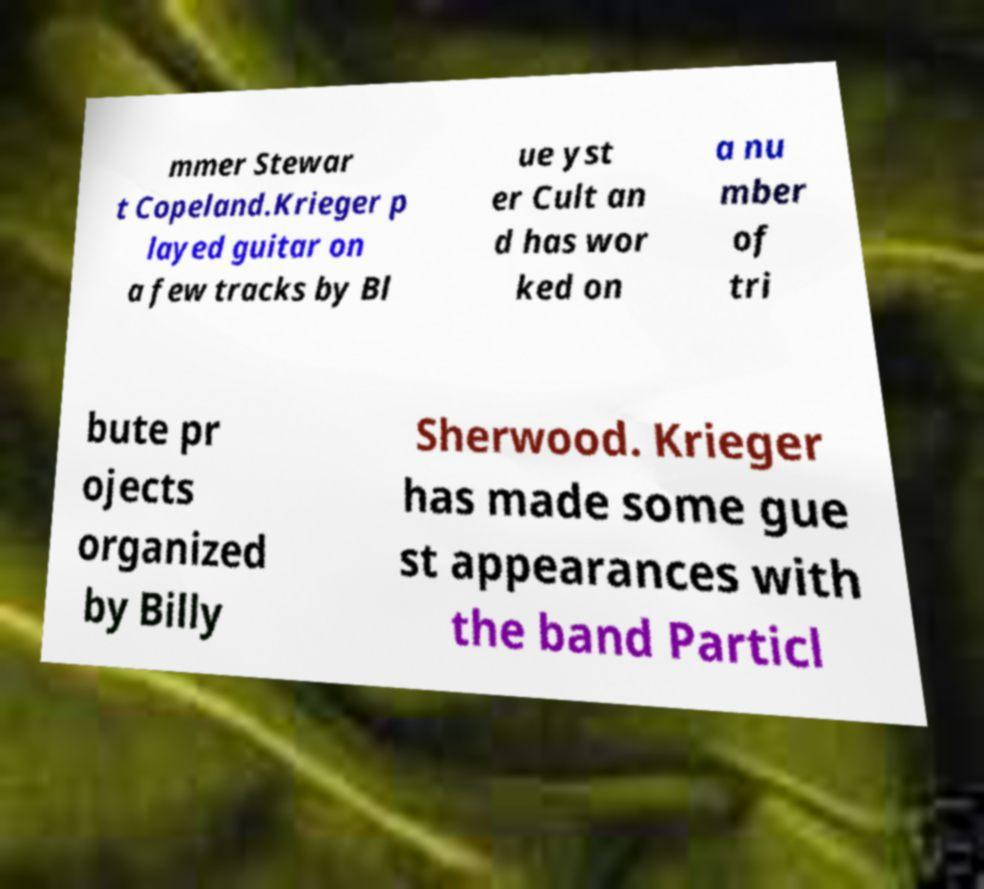What messages or text are displayed in this image? I need them in a readable, typed format. mmer Stewar t Copeland.Krieger p layed guitar on a few tracks by Bl ue yst er Cult an d has wor ked on a nu mber of tri bute pr ojects organized by Billy Sherwood. Krieger has made some gue st appearances with the band Particl 